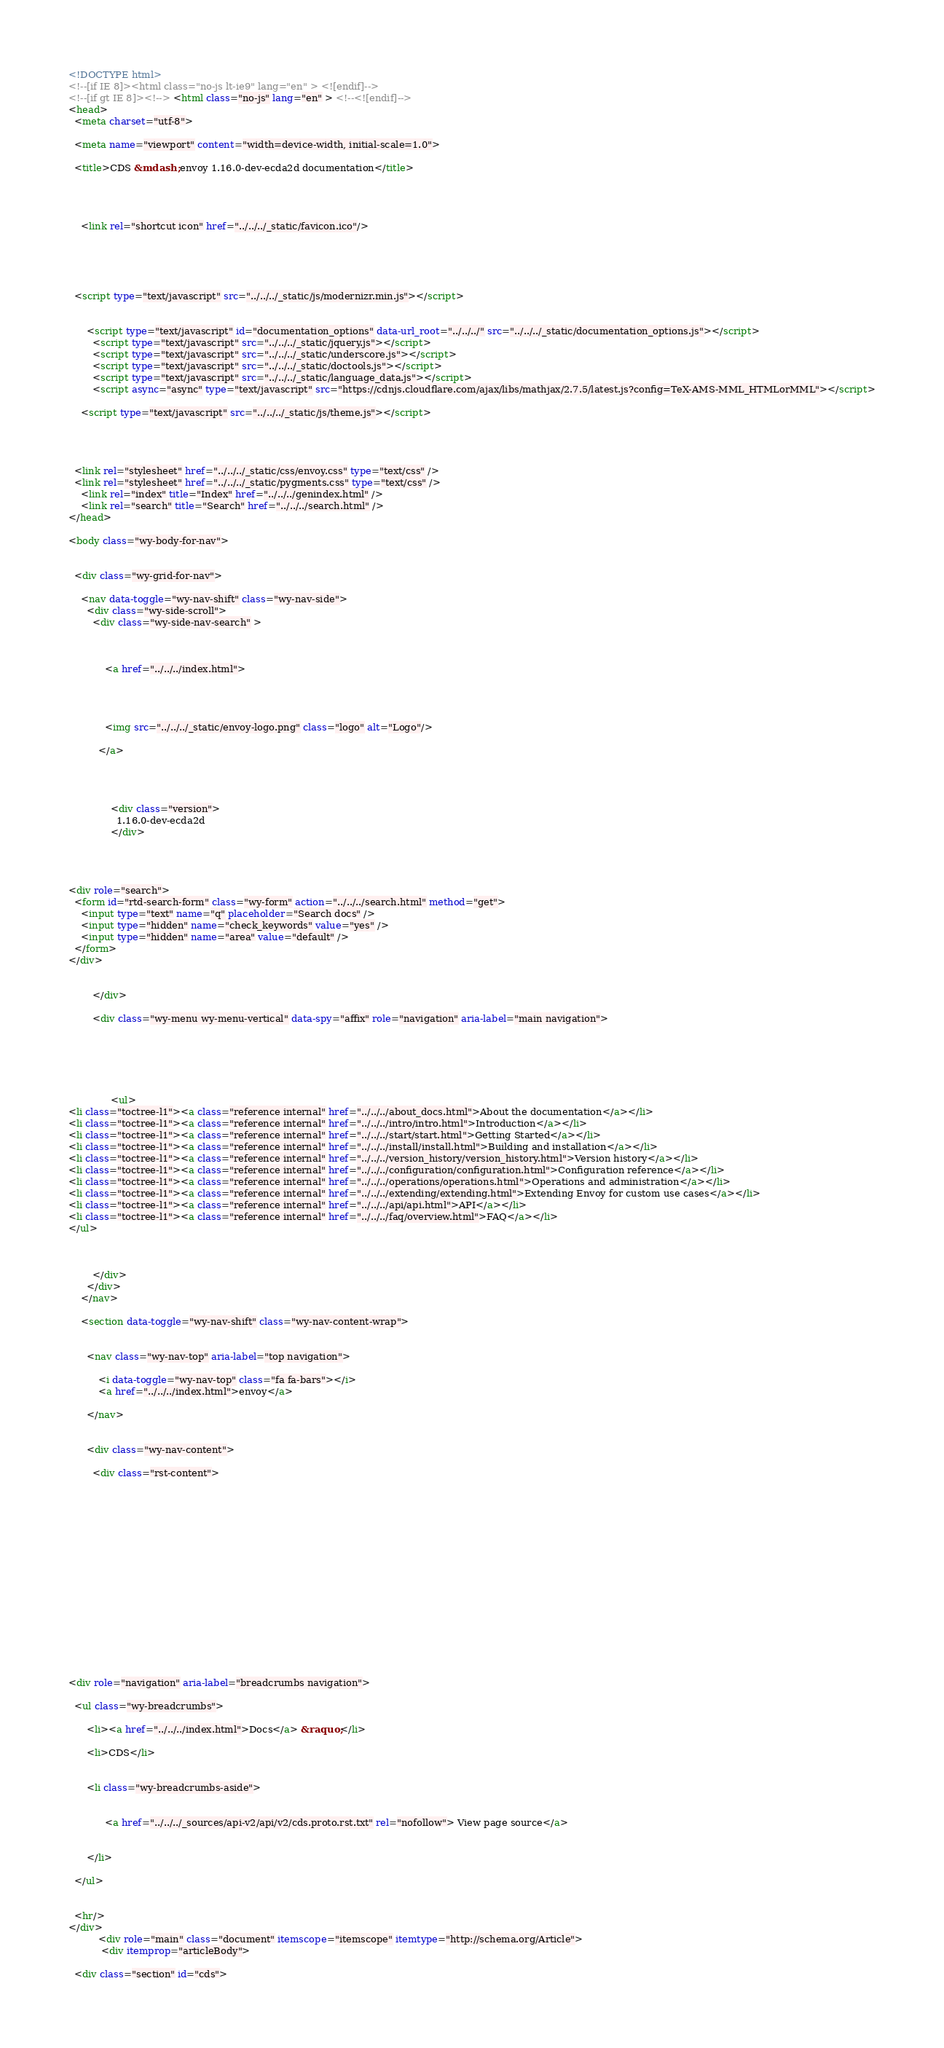Convert code to text. <code><loc_0><loc_0><loc_500><loc_500><_HTML_>

<!DOCTYPE html>
<!--[if IE 8]><html class="no-js lt-ie9" lang="en" > <![endif]-->
<!--[if gt IE 8]><!--> <html class="no-js" lang="en" > <!--<![endif]-->
<head>
  <meta charset="utf-8">
  
  <meta name="viewport" content="width=device-width, initial-scale=1.0">
  
  <title>CDS &mdash; envoy 1.16.0-dev-ecda2d documentation</title>
  

  
  
    <link rel="shortcut icon" href="../../../_static/favicon.ico"/>
  
  
  

  
  <script type="text/javascript" src="../../../_static/js/modernizr.min.js"></script>
  
    
      <script type="text/javascript" id="documentation_options" data-url_root="../../../" src="../../../_static/documentation_options.js"></script>
        <script type="text/javascript" src="../../../_static/jquery.js"></script>
        <script type="text/javascript" src="../../../_static/underscore.js"></script>
        <script type="text/javascript" src="../../../_static/doctools.js"></script>
        <script type="text/javascript" src="../../../_static/language_data.js"></script>
        <script async="async" type="text/javascript" src="https://cdnjs.cloudflare.com/ajax/libs/mathjax/2.7.5/latest.js?config=TeX-AMS-MML_HTMLorMML"></script>
    
    <script type="text/javascript" src="../../../_static/js/theme.js"></script>

    

  
  <link rel="stylesheet" href="../../../_static/css/envoy.css" type="text/css" />
  <link rel="stylesheet" href="../../../_static/pygments.css" type="text/css" />
    <link rel="index" title="Index" href="../../../genindex.html" />
    <link rel="search" title="Search" href="../../../search.html" /> 
</head>

<body class="wy-body-for-nav">

   
  <div class="wy-grid-for-nav">
    
    <nav data-toggle="wy-nav-shift" class="wy-nav-side">
      <div class="wy-side-scroll">
        <div class="wy-side-nav-search" >
          

          
            <a href="../../../index.html">
          

          
            
            <img src="../../../_static/envoy-logo.png" class="logo" alt="Logo"/>
          
          </a>

          
            
            
              <div class="version">
                1.16.0-dev-ecda2d
              </div>
            
          

          
<div role="search">
  <form id="rtd-search-form" class="wy-form" action="../../../search.html" method="get">
    <input type="text" name="q" placeholder="Search docs" />
    <input type="hidden" name="check_keywords" value="yes" />
    <input type="hidden" name="area" value="default" />
  </form>
</div>

          
        </div>

        <div class="wy-menu wy-menu-vertical" data-spy="affix" role="navigation" aria-label="main navigation">
          
            
            
              
            
            
              <ul>
<li class="toctree-l1"><a class="reference internal" href="../../../about_docs.html">About the documentation</a></li>
<li class="toctree-l1"><a class="reference internal" href="../../../intro/intro.html">Introduction</a></li>
<li class="toctree-l1"><a class="reference internal" href="../../../start/start.html">Getting Started</a></li>
<li class="toctree-l1"><a class="reference internal" href="../../../install/install.html">Building and installation</a></li>
<li class="toctree-l1"><a class="reference internal" href="../../../version_history/version_history.html">Version history</a></li>
<li class="toctree-l1"><a class="reference internal" href="../../../configuration/configuration.html">Configuration reference</a></li>
<li class="toctree-l1"><a class="reference internal" href="../../../operations/operations.html">Operations and administration</a></li>
<li class="toctree-l1"><a class="reference internal" href="../../../extending/extending.html">Extending Envoy for custom use cases</a></li>
<li class="toctree-l1"><a class="reference internal" href="../../../api/api.html">API</a></li>
<li class="toctree-l1"><a class="reference internal" href="../../../faq/overview.html">FAQ</a></li>
</ul>

            
          
        </div>
      </div>
    </nav>

    <section data-toggle="wy-nav-shift" class="wy-nav-content-wrap">

      
      <nav class="wy-nav-top" aria-label="top navigation">
        
          <i data-toggle="wy-nav-top" class="fa fa-bars"></i>
          <a href="../../../index.html">envoy</a>
        
      </nav>


      <div class="wy-nav-content">
        
        <div class="rst-content">
        
          















<div role="navigation" aria-label="breadcrumbs navigation">

  <ul class="wy-breadcrumbs">
    
      <li><a href="../../../index.html">Docs</a> &raquo;</li>
        
      <li>CDS</li>
    
    
      <li class="wy-breadcrumbs-aside">
        
            
            <a href="../../../_sources/api-v2/api/v2/cds.proto.rst.txt" rel="nofollow"> View page source</a>
          
        
      </li>
    
  </ul>

  
  <hr/>
</div>
          <div role="main" class="document" itemscope="itemscope" itemtype="http://schema.org/Article">
           <div itemprop="articleBody">
            
  <div class="section" id="cds"></code> 